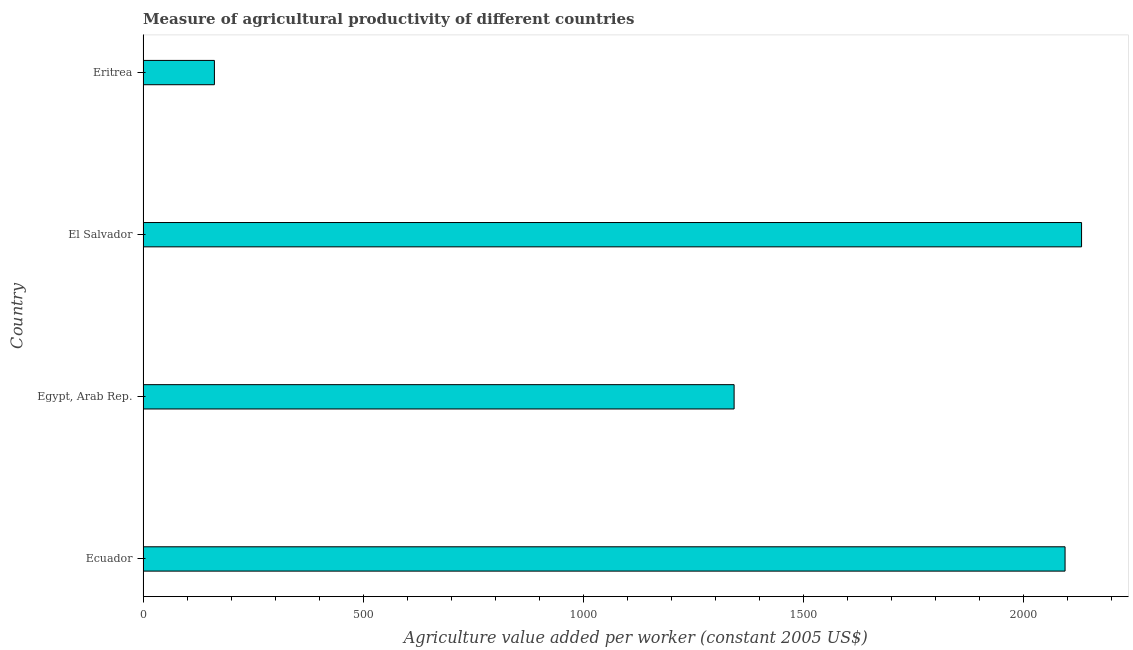What is the title of the graph?
Ensure brevity in your answer.  Measure of agricultural productivity of different countries. What is the label or title of the X-axis?
Provide a succinct answer. Agriculture value added per worker (constant 2005 US$). What is the label or title of the Y-axis?
Your answer should be very brief. Country. What is the agriculture value added per worker in Eritrea?
Give a very brief answer. 162.02. Across all countries, what is the maximum agriculture value added per worker?
Your answer should be very brief. 2131.11. Across all countries, what is the minimum agriculture value added per worker?
Offer a terse response. 162.02. In which country was the agriculture value added per worker maximum?
Your response must be concise. El Salvador. In which country was the agriculture value added per worker minimum?
Make the answer very short. Eritrea. What is the sum of the agriculture value added per worker?
Your response must be concise. 5728.88. What is the difference between the agriculture value added per worker in Egypt, Arab Rep. and Eritrea?
Your answer should be very brief. 1180.09. What is the average agriculture value added per worker per country?
Provide a short and direct response. 1432.22. What is the median agriculture value added per worker?
Your response must be concise. 1717.87. What is the ratio of the agriculture value added per worker in Egypt, Arab Rep. to that in El Salvador?
Provide a succinct answer. 0.63. What is the difference between the highest and the second highest agriculture value added per worker?
Keep it short and to the point. 37.47. What is the difference between the highest and the lowest agriculture value added per worker?
Give a very brief answer. 1969.09. Are all the bars in the graph horizontal?
Give a very brief answer. Yes. What is the Agriculture value added per worker (constant 2005 US$) of Ecuador?
Keep it short and to the point. 2093.64. What is the Agriculture value added per worker (constant 2005 US$) in Egypt, Arab Rep.?
Offer a terse response. 1342.1. What is the Agriculture value added per worker (constant 2005 US$) of El Salvador?
Make the answer very short. 2131.11. What is the Agriculture value added per worker (constant 2005 US$) in Eritrea?
Your answer should be compact. 162.02. What is the difference between the Agriculture value added per worker (constant 2005 US$) in Ecuador and Egypt, Arab Rep.?
Give a very brief answer. 751.54. What is the difference between the Agriculture value added per worker (constant 2005 US$) in Ecuador and El Salvador?
Offer a very short reply. -37.47. What is the difference between the Agriculture value added per worker (constant 2005 US$) in Ecuador and Eritrea?
Keep it short and to the point. 1931.63. What is the difference between the Agriculture value added per worker (constant 2005 US$) in Egypt, Arab Rep. and El Salvador?
Provide a succinct answer. -789.01. What is the difference between the Agriculture value added per worker (constant 2005 US$) in Egypt, Arab Rep. and Eritrea?
Keep it short and to the point. 1180.08. What is the difference between the Agriculture value added per worker (constant 2005 US$) in El Salvador and Eritrea?
Provide a short and direct response. 1969.09. What is the ratio of the Agriculture value added per worker (constant 2005 US$) in Ecuador to that in Egypt, Arab Rep.?
Make the answer very short. 1.56. What is the ratio of the Agriculture value added per worker (constant 2005 US$) in Ecuador to that in El Salvador?
Provide a succinct answer. 0.98. What is the ratio of the Agriculture value added per worker (constant 2005 US$) in Ecuador to that in Eritrea?
Your answer should be very brief. 12.92. What is the ratio of the Agriculture value added per worker (constant 2005 US$) in Egypt, Arab Rep. to that in El Salvador?
Your answer should be very brief. 0.63. What is the ratio of the Agriculture value added per worker (constant 2005 US$) in Egypt, Arab Rep. to that in Eritrea?
Keep it short and to the point. 8.28. What is the ratio of the Agriculture value added per worker (constant 2005 US$) in El Salvador to that in Eritrea?
Ensure brevity in your answer.  13.15. 